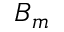<formula> <loc_0><loc_0><loc_500><loc_500>B _ { m }</formula> 